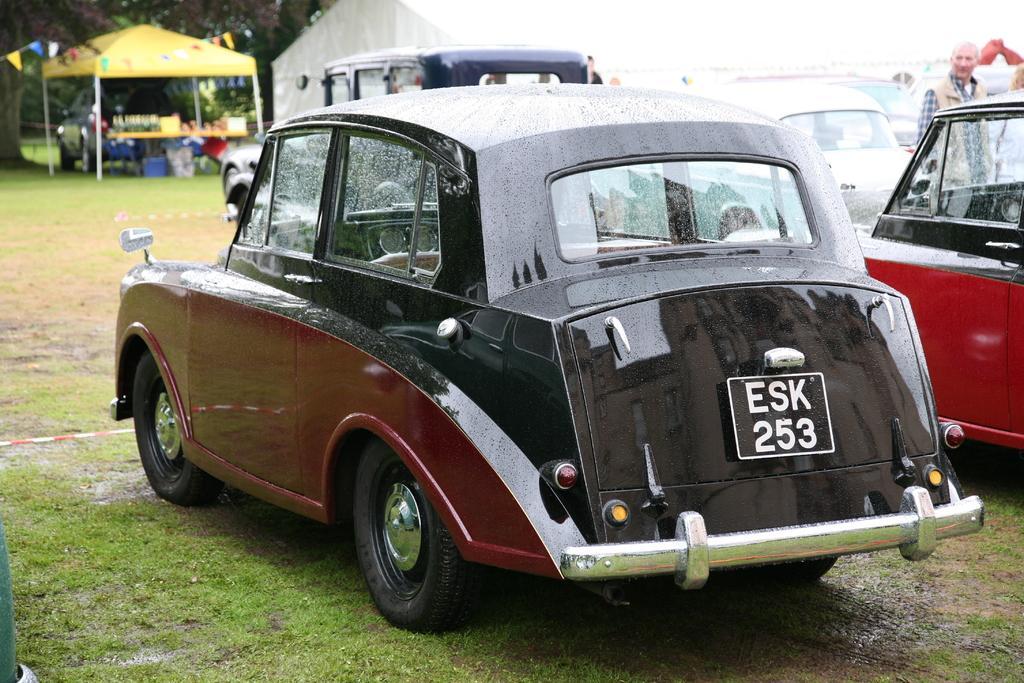Please provide a concise description of this image. This picture shows a few cars parked one is red in color and another one is black and red in color and we see a man standing and we see tents on the side and grass on the ground. 